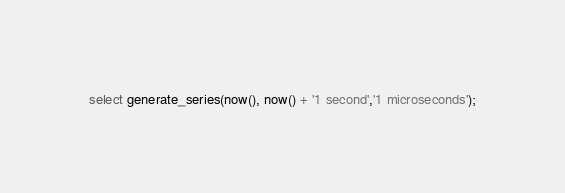<code> <loc_0><loc_0><loc_500><loc_500><_SQL_>select generate_series(now(), now() + '1 second','1 microseconds');</code> 